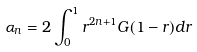Convert formula to latex. <formula><loc_0><loc_0><loc_500><loc_500>\alpha _ { n } = 2 \int _ { 0 } ^ { 1 } r ^ { 2 n + 1 } G ( 1 - r ) d r</formula> 